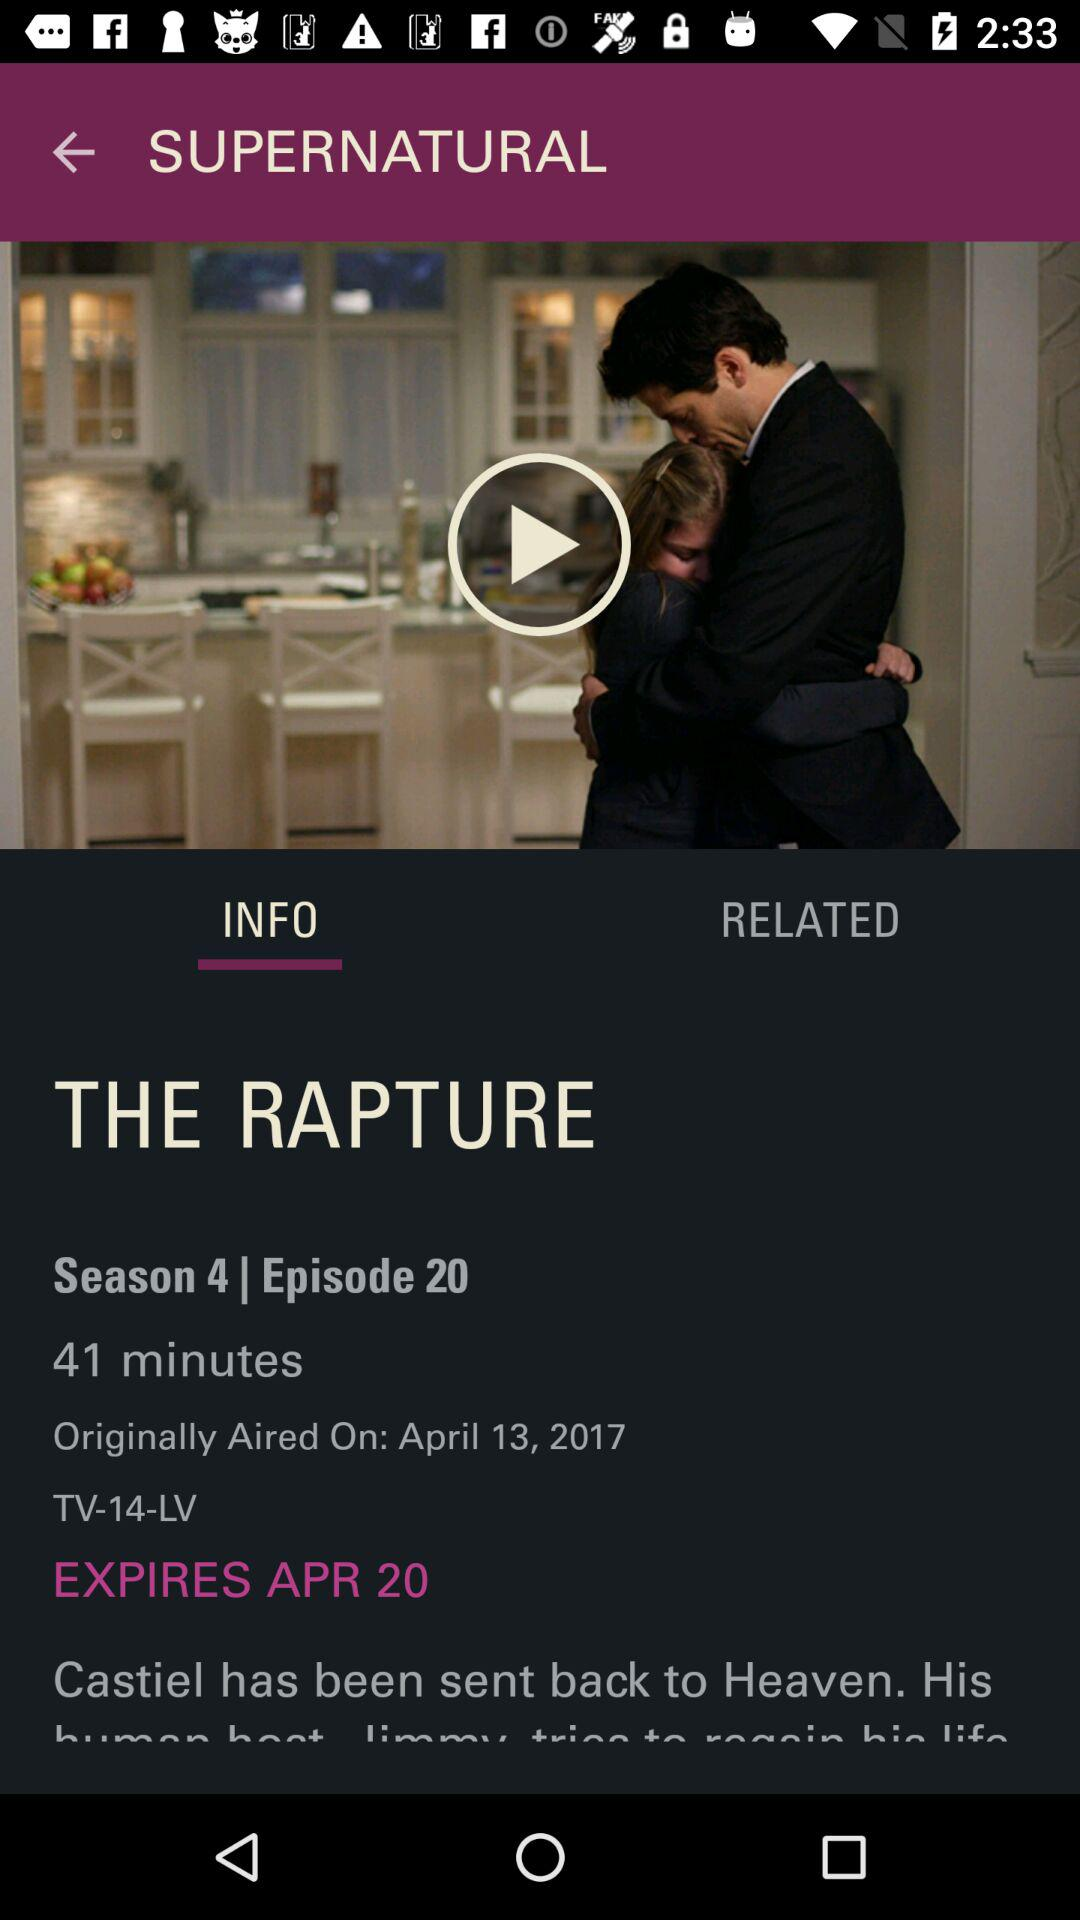On which date episode will expire? The episode will expire on April 20. 